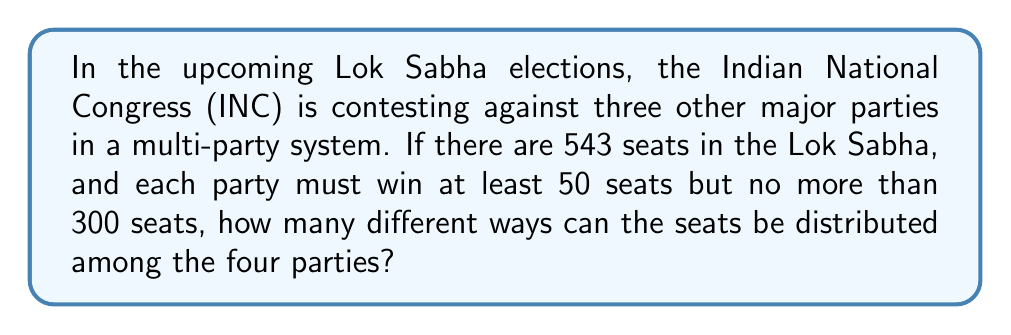Help me with this question. Let's approach this step-by-step:

1) This is a problem of distributing 543 seats among 4 parties with restrictions. We can use the stars and bars method with modifications.

2) Let $x_1, x_2, x_3, x_4$ represent the seats won by each party. We need to find the number of non-negative integer solutions to:

   $x_1 + x_2 + x_3 + x_4 = 543$

   subject to $50 \leq x_i \leq 300$ for all $i$.

3) To handle the lower bound, we can allocate 50 seats to each party first:

   $(x_1 + 50) + (x_2 + 50) + (x_3 + 50) + (x_4 + 50) = 543 + 200$

   $y_1 + y_2 + y_3 + y_4 = 743$

   where $0 \leq y_i \leq 250$ for all $i$.

4) Now we need to find the number of solutions to this equation and subtract the solutions where any $y_i > 250$.

5) The total number of solutions without the upper bound is:

   $\binom{743 + 4 - 1}{4 - 1} = \binom{746}{3}$

6) To exclude solutions where any $y_i > 250$, we use the Principle of Inclusion-Exclusion:

   - Solutions with at least one $y_i > 250$: $\binom{4}{1}\binom{496}{3}$
   - Solutions with at least two $y_i > 250$: $\binom{4}{2}\binom{246}{3}$
   - Solutions with at least three $y_i > 250$: $\binom{4}{3}\binom{-4}{3} = 0$
   - Solutions with all four $y_i > 250$: $\binom{4}{4}\binom{-254}{3} = 0$

7) Therefore, the final answer is:

   $\binom{746}{3} - \binom{4}{1}\binom{496}{3} + \binom{4}{2}\binom{246}{3}$
Answer: $$\binom{746}{3} - 4\binom{496}{3} + 6\binom{246}{3} = 6,855,936$$ 